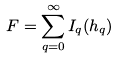<formula> <loc_0><loc_0><loc_500><loc_500>F = \sum _ { q = 0 } ^ { \infty } I _ { q } ( h _ { q } )</formula> 